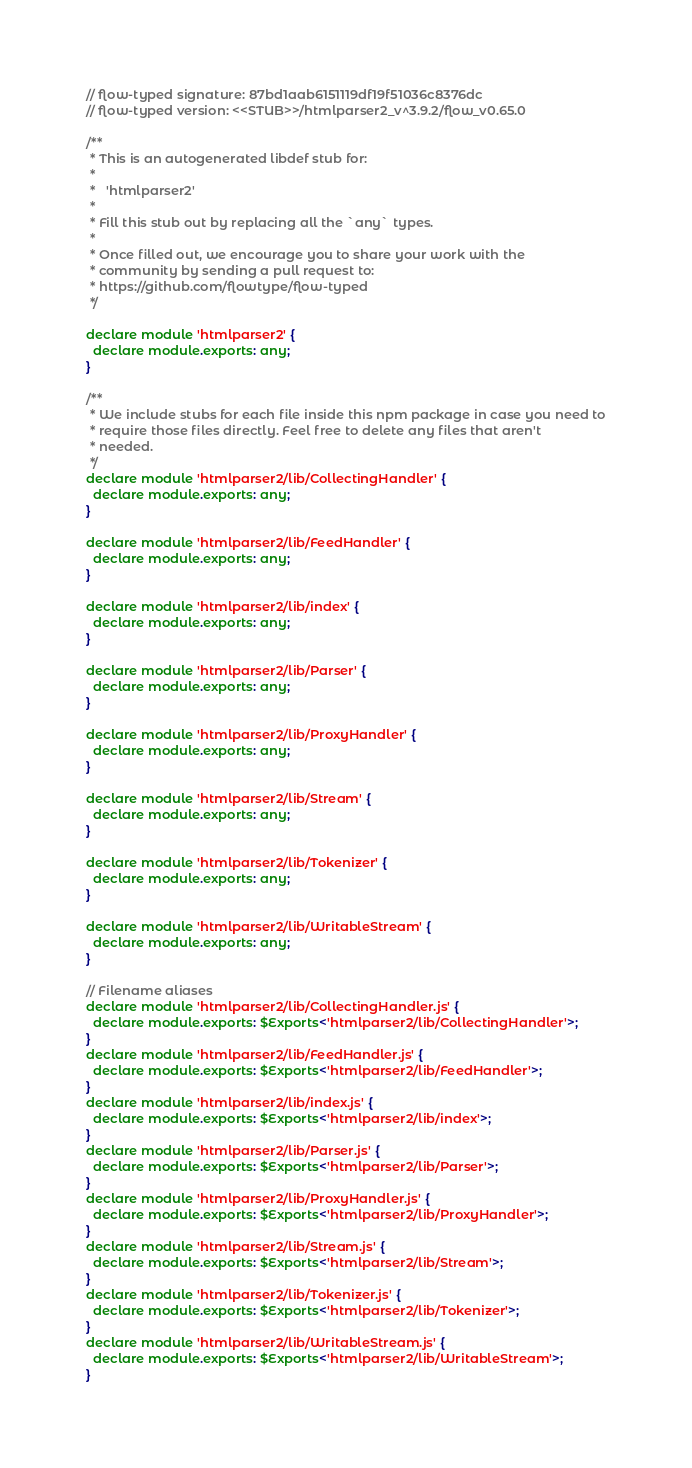Convert code to text. <code><loc_0><loc_0><loc_500><loc_500><_JavaScript_>// flow-typed signature: 87bd1aab6151119df19f51036c8376dc
// flow-typed version: <<STUB>>/htmlparser2_v^3.9.2/flow_v0.65.0

/**
 * This is an autogenerated libdef stub for:
 *
 *   'htmlparser2'
 *
 * Fill this stub out by replacing all the `any` types.
 *
 * Once filled out, we encourage you to share your work with the
 * community by sending a pull request to:
 * https://github.com/flowtype/flow-typed
 */

declare module 'htmlparser2' {
  declare module.exports: any;
}

/**
 * We include stubs for each file inside this npm package in case you need to
 * require those files directly. Feel free to delete any files that aren't
 * needed.
 */
declare module 'htmlparser2/lib/CollectingHandler' {
  declare module.exports: any;
}

declare module 'htmlparser2/lib/FeedHandler' {
  declare module.exports: any;
}

declare module 'htmlparser2/lib/index' {
  declare module.exports: any;
}

declare module 'htmlparser2/lib/Parser' {
  declare module.exports: any;
}

declare module 'htmlparser2/lib/ProxyHandler' {
  declare module.exports: any;
}

declare module 'htmlparser2/lib/Stream' {
  declare module.exports: any;
}

declare module 'htmlparser2/lib/Tokenizer' {
  declare module.exports: any;
}

declare module 'htmlparser2/lib/WritableStream' {
  declare module.exports: any;
}

// Filename aliases
declare module 'htmlparser2/lib/CollectingHandler.js' {
  declare module.exports: $Exports<'htmlparser2/lib/CollectingHandler'>;
}
declare module 'htmlparser2/lib/FeedHandler.js' {
  declare module.exports: $Exports<'htmlparser2/lib/FeedHandler'>;
}
declare module 'htmlparser2/lib/index.js' {
  declare module.exports: $Exports<'htmlparser2/lib/index'>;
}
declare module 'htmlparser2/lib/Parser.js' {
  declare module.exports: $Exports<'htmlparser2/lib/Parser'>;
}
declare module 'htmlparser2/lib/ProxyHandler.js' {
  declare module.exports: $Exports<'htmlparser2/lib/ProxyHandler'>;
}
declare module 'htmlparser2/lib/Stream.js' {
  declare module.exports: $Exports<'htmlparser2/lib/Stream'>;
}
declare module 'htmlparser2/lib/Tokenizer.js' {
  declare module.exports: $Exports<'htmlparser2/lib/Tokenizer'>;
}
declare module 'htmlparser2/lib/WritableStream.js' {
  declare module.exports: $Exports<'htmlparser2/lib/WritableStream'>;
}
</code> 